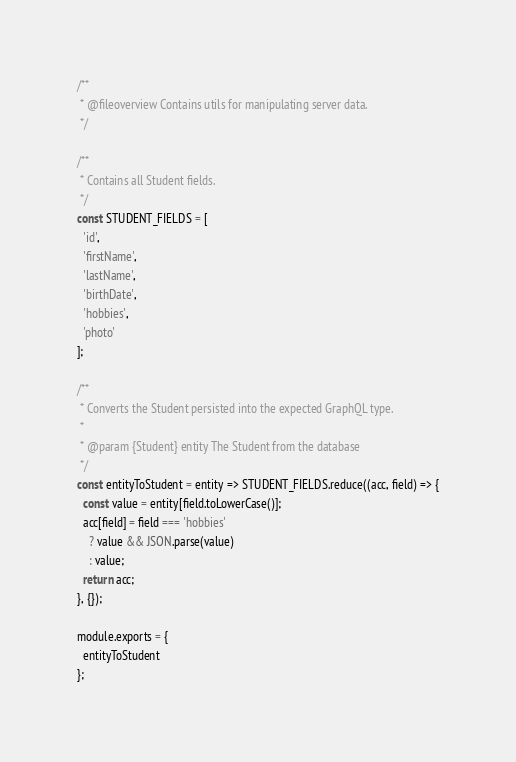<code> <loc_0><loc_0><loc_500><loc_500><_JavaScript_>/**
 * @fileoverview Contains utils for manipulating server data.
 */

/**
 * Contains all Student fields.
 */
const STUDENT_FIELDS = [
  'id',
  'firstName',
  'lastName',
  'birthDate',
  'hobbies',
  'photo'
];

/**
 * Converts the Student persisted into the expected GraphQL type.
 *
 * @param {Student} entity The Student from the database
 */
const entityToStudent = entity => STUDENT_FIELDS.reduce((acc, field) => {
  const value = entity[field.toLowerCase()];
  acc[field] = field === 'hobbies'
    ? value && JSON.parse(value)
    : value;
  return acc;
}, {});

module.exports = {
  entityToStudent
};</code> 